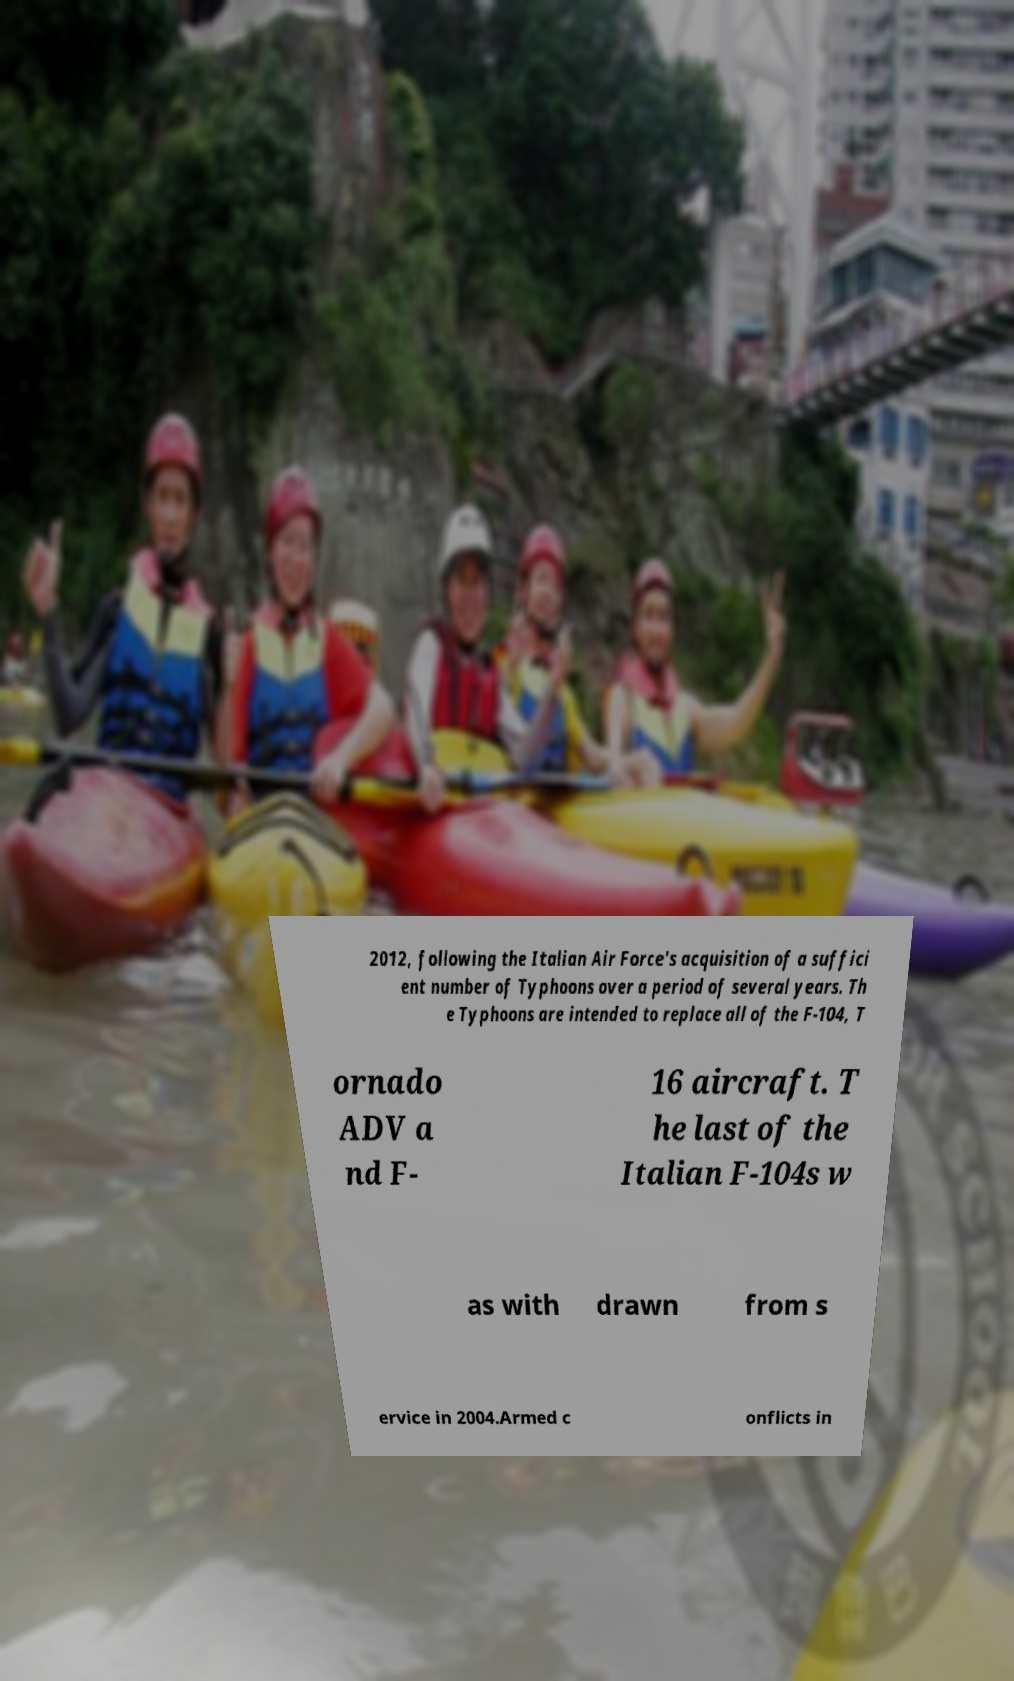Please identify and transcribe the text found in this image. 2012, following the Italian Air Force's acquisition of a suffici ent number of Typhoons over a period of several years. Th e Typhoons are intended to replace all of the F-104, T ornado ADV a nd F- 16 aircraft. T he last of the Italian F-104s w as with drawn from s ervice in 2004.Armed c onflicts in 